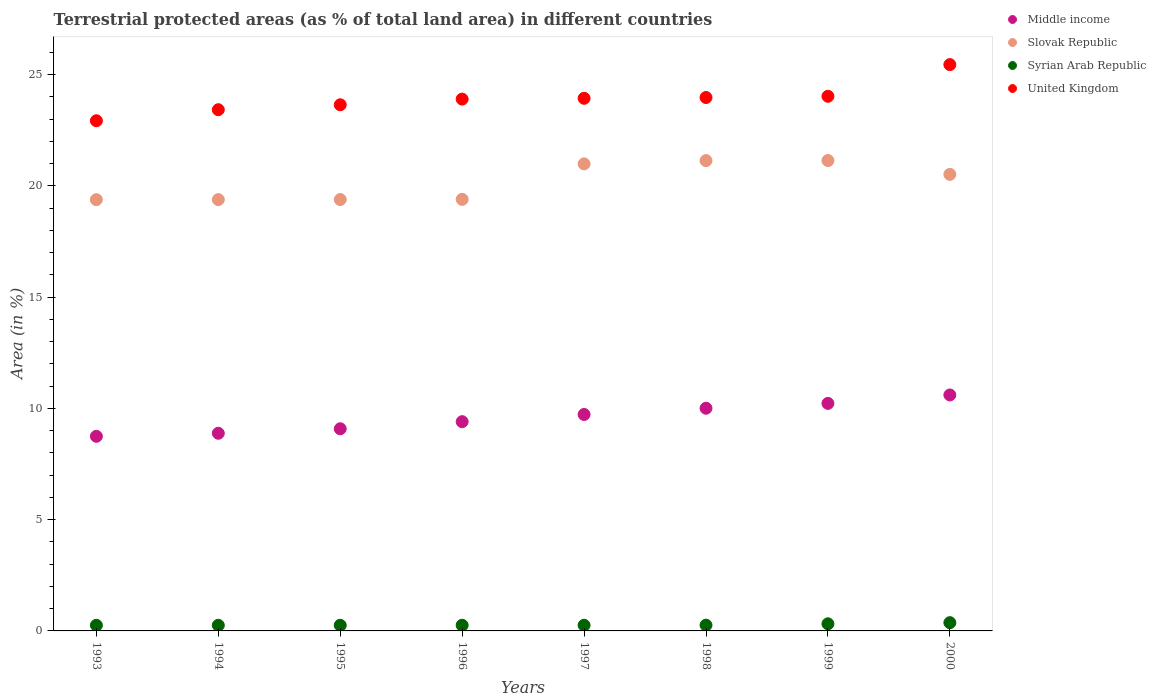Is the number of dotlines equal to the number of legend labels?
Your answer should be compact. Yes. What is the percentage of terrestrial protected land in Syrian Arab Republic in 1997?
Provide a succinct answer. 0.25. Across all years, what is the maximum percentage of terrestrial protected land in Syrian Arab Republic?
Keep it short and to the point. 0.37. Across all years, what is the minimum percentage of terrestrial protected land in United Kingdom?
Provide a short and direct response. 22.93. In which year was the percentage of terrestrial protected land in Slovak Republic minimum?
Your answer should be very brief. 1993. What is the total percentage of terrestrial protected land in Syrian Arab Republic in the graph?
Make the answer very short. 2.22. What is the difference between the percentage of terrestrial protected land in United Kingdom in 1993 and that in 1997?
Offer a terse response. -1.01. What is the difference between the percentage of terrestrial protected land in United Kingdom in 1994 and the percentage of terrestrial protected land in Slovak Republic in 1995?
Your answer should be very brief. 4.04. What is the average percentage of terrestrial protected land in United Kingdom per year?
Offer a terse response. 23.91. In the year 1997, what is the difference between the percentage of terrestrial protected land in Syrian Arab Republic and percentage of terrestrial protected land in Middle income?
Provide a short and direct response. -9.47. In how many years, is the percentage of terrestrial protected land in Middle income greater than 2 %?
Provide a succinct answer. 8. What is the ratio of the percentage of terrestrial protected land in Middle income in 1999 to that in 2000?
Provide a short and direct response. 0.96. Is the percentage of terrestrial protected land in Syrian Arab Republic in 1997 less than that in 1999?
Your response must be concise. Yes. Is the difference between the percentage of terrestrial protected land in Syrian Arab Republic in 1996 and 1999 greater than the difference between the percentage of terrestrial protected land in Middle income in 1996 and 1999?
Ensure brevity in your answer.  Yes. What is the difference between the highest and the second highest percentage of terrestrial protected land in Middle income?
Your answer should be very brief. 0.38. What is the difference between the highest and the lowest percentage of terrestrial protected land in Middle income?
Make the answer very short. 1.86. In how many years, is the percentage of terrestrial protected land in Slovak Republic greater than the average percentage of terrestrial protected land in Slovak Republic taken over all years?
Give a very brief answer. 4. Is the sum of the percentage of terrestrial protected land in Middle income in 1994 and 1999 greater than the maximum percentage of terrestrial protected land in United Kingdom across all years?
Provide a short and direct response. No. Is it the case that in every year, the sum of the percentage of terrestrial protected land in Syrian Arab Republic and percentage of terrestrial protected land in Middle income  is greater than the sum of percentage of terrestrial protected land in United Kingdom and percentage of terrestrial protected land in Slovak Republic?
Provide a short and direct response. No. Does the percentage of terrestrial protected land in Middle income monotonically increase over the years?
Your response must be concise. Yes. How many dotlines are there?
Your answer should be very brief. 4. How many years are there in the graph?
Give a very brief answer. 8. What is the difference between two consecutive major ticks on the Y-axis?
Give a very brief answer. 5. Are the values on the major ticks of Y-axis written in scientific E-notation?
Offer a very short reply. No. Where does the legend appear in the graph?
Your response must be concise. Top right. How many legend labels are there?
Offer a terse response. 4. How are the legend labels stacked?
Keep it short and to the point. Vertical. What is the title of the graph?
Provide a short and direct response. Terrestrial protected areas (as % of total land area) in different countries. Does "Zambia" appear as one of the legend labels in the graph?
Offer a terse response. No. What is the label or title of the X-axis?
Give a very brief answer. Years. What is the label or title of the Y-axis?
Your response must be concise. Area (in %). What is the Area (in %) in Middle income in 1993?
Ensure brevity in your answer.  8.75. What is the Area (in %) of Slovak Republic in 1993?
Provide a succinct answer. 19.38. What is the Area (in %) of Syrian Arab Republic in 1993?
Ensure brevity in your answer.  0.25. What is the Area (in %) in United Kingdom in 1993?
Your answer should be very brief. 22.93. What is the Area (in %) in Middle income in 1994?
Give a very brief answer. 8.88. What is the Area (in %) of Slovak Republic in 1994?
Ensure brevity in your answer.  19.38. What is the Area (in %) of Syrian Arab Republic in 1994?
Make the answer very short. 0.25. What is the Area (in %) in United Kingdom in 1994?
Provide a succinct answer. 23.43. What is the Area (in %) in Middle income in 1995?
Offer a very short reply. 9.09. What is the Area (in %) in Slovak Republic in 1995?
Provide a succinct answer. 19.39. What is the Area (in %) in Syrian Arab Republic in 1995?
Offer a terse response. 0.25. What is the Area (in %) in United Kingdom in 1995?
Offer a very short reply. 23.65. What is the Area (in %) in Middle income in 1996?
Ensure brevity in your answer.  9.4. What is the Area (in %) in Slovak Republic in 1996?
Make the answer very short. 19.4. What is the Area (in %) of Syrian Arab Republic in 1996?
Offer a very short reply. 0.25. What is the Area (in %) of United Kingdom in 1996?
Your answer should be very brief. 23.9. What is the Area (in %) of Middle income in 1997?
Your response must be concise. 9.73. What is the Area (in %) in Slovak Republic in 1997?
Keep it short and to the point. 20.99. What is the Area (in %) of Syrian Arab Republic in 1997?
Keep it short and to the point. 0.25. What is the Area (in %) of United Kingdom in 1997?
Your answer should be compact. 23.94. What is the Area (in %) of Middle income in 1998?
Ensure brevity in your answer.  10.01. What is the Area (in %) of Slovak Republic in 1998?
Give a very brief answer. 21.14. What is the Area (in %) in Syrian Arab Republic in 1998?
Provide a short and direct response. 0.26. What is the Area (in %) of United Kingdom in 1998?
Your response must be concise. 23.97. What is the Area (in %) in Middle income in 1999?
Provide a succinct answer. 10.23. What is the Area (in %) in Slovak Republic in 1999?
Give a very brief answer. 21.14. What is the Area (in %) of Syrian Arab Republic in 1999?
Keep it short and to the point. 0.32. What is the Area (in %) in United Kingdom in 1999?
Your answer should be very brief. 24.03. What is the Area (in %) of Middle income in 2000?
Your answer should be compact. 10.61. What is the Area (in %) of Slovak Republic in 2000?
Keep it short and to the point. 20.52. What is the Area (in %) in Syrian Arab Republic in 2000?
Your answer should be compact. 0.37. What is the Area (in %) in United Kingdom in 2000?
Your answer should be very brief. 25.45. Across all years, what is the maximum Area (in %) of Middle income?
Your response must be concise. 10.61. Across all years, what is the maximum Area (in %) of Slovak Republic?
Keep it short and to the point. 21.14. Across all years, what is the maximum Area (in %) in Syrian Arab Republic?
Offer a terse response. 0.37. Across all years, what is the maximum Area (in %) of United Kingdom?
Your answer should be very brief. 25.45. Across all years, what is the minimum Area (in %) in Middle income?
Your answer should be compact. 8.75. Across all years, what is the minimum Area (in %) in Slovak Republic?
Offer a terse response. 19.38. Across all years, what is the minimum Area (in %) in Syrian Arab Republic?
Your response must be concise. 0.25. Across all years, what is the minimum Area (in %) in United Kingdom?
Make the answer very short. 22.93. What is the total Area (in %) in Middle income in the graph?
Your answer should be very brief. 76.69. What is the total Area (in %) of Slovak Republic in the graph?
Give a very brief answer. 161.34. What is the total Area (in %) of Syrian Arab Republic in the graph?
Your answer should be compact. 2.22. What is the total Area (in %) of United Kingdom in the graph?
Provide a succinct answer. 191.3. What is the difference between the Area (in %) of Middle income in 1993 and that in 1994?
Ensure brevity in your answer.  -0.14. What is the difference between the Area (in %) in Slovak Republic in 1993 and that in 1994?
Provide a succinct answer. -0. What is the difference between the Area (in %) in Syrian Arab Republic in 1993 and that in 1994?
Ensure brevity in your answer.  0. What is the difference between the Area (in %) of United Kingdom in 1993 and that in 1994?
Your response must be concise. -0.5. What is the difference between the Area (in %) in Middle income in 1993 and that in 1995?
Offer a very short reply. -0.34. What is the difference between the Area (in %) in Slovak Republic in 1993 and that in 1995?
Your answer should be compact. -0.01. What is the difference between the Area (in %) in United Kingdom in 1993 and that in 1995?
Provide a short and direct response. -0.72. What is the difference between the Area (in %) in Middle income in 1993 and that in 1996?
Keep it short and to the point. -0.66. What is the difference between the Area (in %) of Slovak Republic in 1993 and that in 1996?
Offer a very short reply. -0.01. What is the difference between the Area (in %) in Syrian Arab Republic in 1993 and that in 1996?
Your answer should be very brief. -0. What is the difference between the Area (in %) of United Kingdom in 1993 and that in 1996?
Provide a short and direct response. -0.97. What is the difference between the Area (in %) of Middle income in 1993 and that in 1997?
Give a very brief answer. -0.98. What is the difference between the Area (in %) of Slovak Republic in 1993 and that in 1997?
Your response must be concise. -1.61. What is the difference between the Area (in %) in Syrian Arab Republic in 1993 and that in 1997?
Your answer should be compact. -0. What is the difference between the Area (in %) in United Kingdom in 1993 and that in 1997?
Offer a terse response. -1.01. What is the difference between the Area (in %) of Middle income in 1993 and that in 1998?
Your answer should be very brief. -1.26. What is the difference between the Area (in %) of Slovak Republic in 1993 and that in 1998?
Give a very brief answer. -1.76. What is the difference between the Area (in %) in Syrian Arab Republic in 1993 and that in 1998?
Your response must be concise. -0.01. What is the difference between the Area (in %) in United Kingdom in 1993 and that in 1998?
Provide a succinct answer. -1.04. What is the difference between the Area (in %) of Middle income in 1993 and that in 1999?
Your answer should be very brief. -1.48. What is the difference between the Area (in %) of Slovak Republic in 1993 and that in 1999?
Offer a terse response. -1.76. What is the difference between the Area (in %) of Syrian Arab Republic in 1993 and that in 1999?
Provide a succinct answer. -0.07. What is the difference between the Area (in %) in United Kingdom in 1993 and that in 1999?
Provide a short and direct response. -1.1. What is the difference between the Area (in %) in Middle income in 1993 and that in 2000?
Provide a succinct answer. -1.86. What is the difference between the Area (in %) in Slovak Republic in 1993 and that in 2000?
Your answer should be compact. -1.14. What is the difference between the Area (in %) of Syrian Arab Republic in 1993 and that in 2000?
Offer a very short reply. -0.12. What is the difference between the Area (in %) of United Kingdom in 1993 and that in 2000?
Make the answer very short. -2.52. What is the difference between the Area (in %) in Middle income in 1994 and that in 1995?
Offer a very short reply. -0.2. What is the difference between the Area (in %) in Slovak Republic in 1994 and that in 1995?
Ensure brevity in your answer.  -0. What is the difference between the Area (in %) in United Kingdom in 1994 and that in 1995?
Offer a terse response. -0.22. What is the difference between the Area (in %) of Middle income in 1994 and that in 1996?
Your answer should be very brief. -0.52. What is the difference between the Area (in %) in Slovak Republic in 1994 and that in 1996?
Your answer should be compact. -0.01. What is the difference between the Area (in %) of Syrian Arab Republic in 1994 and that in 1996?
Your response must be concise. -0. What is the difference between the Area (in %) in United Kingdom in 1994 and that in 1996?
Provide a short and direct response. -0.48. What is the difference between the Area (in %) of Middle income in 1994 and that in 1997?
Your response must be concise. -0.85. What is the difference between the Area (in %) of Slovak Republic in 1994 and that in 1997?
Offer a terse response. -1.61. What is the difference between the Area (in %) of Syrian Arab Republic in 1994 and that in 1997?
Keep it short and to the point. -0. What is the difference between the Area (in %) in United Kingdom in 1994 and that in 1997?
Offer a very short reply. -0.51. What is the difference between the Area (in %) in Middle income in 1994 and that in 1998?
Keep it short and to the point. -1.13. What is the difference between the Area (in %) in Slovak Republic in 1994 and that in 1998?
Your response must be concise. -1.75. What is the difference between the Area (in %) in Syrian Arab Republic in 1994 and that in 1998?
Provide a short and direct response. -0.01. What is the difference between the Area (in %) of United Kingdom in 1994 and that in 1998?
Your answer should be very brief. -0.55. What is the difference between the Area (in %) of Middle income in 1994 and that in 1999?
Give a very brief answer. -1.34. What is the difference between the Area (in %) in Slovak Republic in 1994 and that in 1999?
Provide a short and direct response. -1.76. What is the difference between the Area (in %) in Syrian Arab Republic in 1994 and that in 1999?
Offer a terse response. -0.07. What is the difference between the Area (in %) in United Kingdom in 1994 and that in 1999?
Provide a short and direct response. -0.6. What is the difference between the Area (in %) in Middle income in 1994 and that in 2000?
Keep it short and to the point. -1.72. What is the difference between the Area (in %) in Slovak Republic in 1994 and that in 2000?
Provide a succinct answer. -1.13. What is the difference between the Area (in %) in Syrian Arab Republic in 1994 and that in 2000?
Provide a short and direct response. -0.12. What is the difference between the Area (in %) in United Kingdom in 1994 and that in 2000?
Provide a succinct answer. -2.03. What is the difference between the Area (in %) in Middle income in 1995 and that in 1996?
Keep it short and to the point. -0.32. What is the difference between the Area (in %) of Slovak Republic in 1995 and that in 1996?
Offer a terse response. -0.01. What is the difference between the Area (in %) of Syrian Arab Republic in 1995 and that in 1996?
Ensure brevity in your answer.  -0. What is the difference between the Area (in %) of United Kingdom in 1995 and that in 1996?
Offer a terse response. -0.26. What is the difference between the Area (in %) of Middle income in 1995 and that in 1997?
Offer a terse response. -0.64. What is the difference between the Area (in %) in Slovak Republic in 1995 and that in 1997?
Provide a succinct answer. -1.6. What is the difference between the Area (in %) in Syrian Arab Republic in 1995 and that in 1997?
Keep it short and to the point. -0. What is the difference between the Area (in %) in United Kingdom in 1995 and that in 1997?
Give a very brief answer. -0.29. What is the difference between the Area (in %) in Middle income in 1995 and that in 1998?
Offer a terse response. -0.92. What is the difference between the Area (in %) in Slovak Republic in 1995 and that in 1998?
Ensure brevity in your answer.  -1.75. What is the difference between the Area (in %) of Syrian Arab Republic in 1995 and that in 1998?
Offer a terse response. -0.01. What is the difference between the Area (in %) of United Kingdom in 1995 and that in 1998?
Your answer should be compact. -0.33. What is the difference between the Area (in %) of Middle income in 1995 and that in 1999?
Make the answer very short. -1.14. What is the difference between the Area (in %) in Slovak Republic in 1995 and that in 1999?
Make the answer very short. -1.75. What is the difference between the Area (in %) of Syrian Arab Republic in 1995 and that in 1999?
Make the answer very short. -0.07. What is the difference between the Area (in %) of United Kingdom in 1995 and that in 1999?
Offer a terse response. -0.38. What is the difference between the Area (in %) in Middle income in 1995 and that in 2000?
Offer a very short reply. -1.52. What is the difference between the Area (in %) in Slovak Republic in 1995 and that in 2000?
Offer a terse response. -1.13. What is the difference between the Area (in %) in Syrian Arab Republic in 1995 and that in 2000?
Give a very brief answer. -0.12. What is the difference between the Area (in %) of United Kingdom in 1995 and that in 2000?
Give a very brief answer. -1.81. What is the difference between the Area (in %) in Middle income in 1996 and that in 1997?
Your answer should be very brief. -0.32. What is the difference between the Area (in %) of Slovak Republic in 1996 and that in 1997?
Ensure brevity in your answer.  -1.59. What is the difference between the Area (in %) in Syrian Arab Republic in 1996 and that in 1997?
Provide a short and direct response. 0. What is the difference between the Area (in %) of United Kingdom in 1996 and that in 1997?
Provide a succinct answer. -0.04. What is the difference between the Area (in %) in Middle income in 1996 and that in 1998?
Offer a very short reply. -0.6. What is the difference between the Area (in %) in Slovak Republic in 1996 and that in 1998?
Offer a very short reply. -1.74. What is the difference between the Area (in %) in Syrian Arab Republic in 1996 and that in 1998?
Provide a succinct answer. -0.01. What is the difference between the Area (in %) in United Kingdom in 1996 and that in 1998?
Keep it short and to the point. -0.07. What is the difference between the Area (in %) of Middle income in 1996 and that in 1999?
Keep it short and to the point. -0.82. What is the difference between the Area (in %) in Slovak Republic in 1996 and that in 1999?
Keep it short and to the point. -1.74. What is the difference between the Area (in %) of Syrian Arab Republic in 1996 and that in 1999?
Ensure brevity in your answer.  -0.07. What is the difference between the Area (in %) of United Kingdom in 1996 and that in 1999?
Your answer should be compact. -0.13. What is the difference between the Area (in %) in Middle income in 1996 and that in 2000?
Offer a very short reply. -1.2. What is the difference between the Area (in %) in Slovak Republic in 1996 and that in 2000?
Provide a succinct answer. -1.12. What is the difference between the Area (in %) of Syrian Arab Republic in 1996 and that in 2000?
Provide a short and direct response. -0.12. What is the difference between the Area (in %) in United Kingdom in 1996 and that in 2000?
Offer a terse response. -1.55. What is the difference between the Area (in %) in Middle income in 1997 and that in 1998?
Your answer should be very brief. -0.28. What is the difference between the Area (in %) of Slovak Republic in 1997 and that in 1998?
Give a very brief answer. -0.15. What is the difference between the Area (in %) of Syrian Arab Republic in 1997 and that in 1998?
Keep it short and to the point. -0.01. What is the difference between the Area (in %) of United Kingdom in 1997 and that in 1998?
Provide a short and direct response. -0.04. What is the difference between the Area (in %) in Middle income in 1997 and that in 1999?
Your answer should be compact. -0.5. What is the difference between the Area (in %) in Slovak Republic in 1997 and that in 1999?
Keep it short and to the point. -0.15. What is the difference between the Area (in %) in Syrian Arab Republic in 1997 and that in 1999?
Provide a succinct answer. -0.07. What is the difference between the Area (in %) in United Kingdom in 1997 and that in 1999?
Offer a terse response. -0.09. What is the difference between the Area (in %) of Middle income in 1997 and that in 2000?
Ensure brevity in your answer.  -0.88. What is the difference between the Area (in %) in Slovak Republic in 1997 and that in 2000?
Give a very brief answer. 0.47. What is the difference between the Area (in %) of Syrian Arab Republic in 1997 and that in 2000?
Give a very brief answer. -0.12. What is the difference between the Area (in %) in United Kingdom in 1997 and that in 2000?
Your answer should be compact. -1.51. What is the difference between the Area (in %) of Middle income in 1998 and that in 1999?
Ensure brevity in your answer.  -0.22. What is the difference between the Area (in %) in Slovak Republic in 1998 and that in 1999?
Your response must be concise. -0. What is the difference between the Area (in %) in Syrian Arab Republic in 1998 and that in 1999?
Give a very brief answer. -0.06. What is the difference between the Area (in %) in United Kingdom in 1998 and that in 1999?
Your response must be concise. -0.05. What is the difference between the Area (in %) in Middle income in 1998 and that in 2000?
Provide a short and direct response. -0.6. What is the difference between the Area (in %) of Slovak Republic in 1998 and that in 2000?
Keep it short and to the point. 0.62. What is the difference between the Area (in %) in Syrian Arab Republic in 1998 and that in 2000?
Offer a very short reply. -0.11. What is the difference between the Area (in %) of United Kingdom in 1998 and that in 2000?
Your answer should be very brief. -1.48. What is the difference between the Area (in %) of Middle income in 1999 and that in 2000?
Provide a short and direct response. -0.38. What is the difference between the Area (in %) in Slovak Republic in 1999 and that in 2000?
Offer a terse response. 0.62. What is the difference between the Area (in %) in Syrian Arab Republic in 1999 and that in 2000?
Keep it short and to the point. -0.05. What is the difference between the Area (in %) in United Kingdom in 1999 and that in 2000?
Your answer should be compact. -1.42. What is the difference between the Area (in %) in Middle income in 1993 and the Area (in %) in Slovak Republic in 1994?
Provide a succinct answer. -10.64. What is the difference between the Area (in %) in Middle income in 1993 and the Area (in %) in Syrian Arab Republic in 1994?
Offer a terse response. 8.49. What is the difference between the Area (in %) of Middle income in 1993 and the Area (in %) of United Kingdom in 1994?
Your response must be concise. -14.68. What is the difference between the Area (in %) in Slovak Republic in 1993 and the Area (in %) in Syrian Arab Republic in 1994?
Give a very brief answer. 19.13. What is the difference between the Area (in %) in Slovak Republic in 1993 and the Area (in %) in United Kingdom in 1994?
Give a very brief answer. -4.04. What is the difference between the Area (in %) in Syrian Arab Republic in 1993 and the Area (in %) in United Kingdom in 1994?
Keep it short and to the point. -23.17. What is the difference between the Area (in %) of Middle income in 1993 and the Area (in %) of Slovak Republic in 1995?
Make the answer very short. -10.64. What is the difference between the Area (in %) in Middle income in 1993 and the Area (in %) in Syrian Arab Republic in 1995?
Provide a succinct answer. 8.49. What is the difference between the Area (in %) in Middle income in 1993 and the Area (in %) in United Kingdom in 1995?
Your answer should be very brief. -14.9. What is the difference between the Area (in %) in Slovak Republic in 1993 and the Area (in %) in Syrian Arab Republic in 1995?
Give a very brief answer. 19.13. What is the difference between the Area (in %) in Slovak Republic in 1993 and the Area (in %) in United Kingdom in 1995?
Your answer should be very brief. -4.26. What is the difference between the Area (in %) in Syrian Arab Republic in 1993 and the Area (in %) in United Kingdom in 1995?
Provide a short and direct response. -23.39. What is the difference between the Area (in %) of Middle income in 1993 and the Area (in %) of Slovak Republic in 1996?
Ensure brevity in your answer.  -10.65. What is the difference between the Area (in %) of Middle income in 1993 and the Area (in %) of Syrian Arab Republic in 1996?
Ensure brevity in your answer.  8.49. What is the difference between the Area (in %) in Middle income in 1993 and the Area (in %) in United Kingdom in 1996?
Your answer should be compact. -15.16. What is the difference between the Area (in %) of Slovak Republic in 1993 and the Area (in %) of Syrian Arab Republic in 1996?
Provide a succinct answer. 19.13. What is the difference between the Area (in %) in Slovak Republic in 1993 and the Area (in %) in United Kingdom in 1996?
Your answer should be compact. -4.52. What is the difference between the Area (in %) in Syrian Arab Republic in 1993 and the Area (in %) in United Kingdom in 1996?
Provide a succinct answer. -23.65. What is the difference between the Area (in %) of Middle income in 1993 and the Area (in %) of Slovak Republic in 1997?
Give a very brief answer. -12.24. What is the difference between the Area (in %) in Middle income in 1993 and the Area (in %) in Syrian Arab Republic in 1997?
Offer a terse response. 8.49. What is the difference between the Area (in %) of Middle income in 1993 and the Area (in %) of United Kingdom in 1997?
Make the answer very short. -15.19. What is the difference between the Area (in %) of Slovak Republic in 1993 and the Area (in %) of Syrian Arab Republic in 1997?
Ensure brevity in your answer.  19.13. What is the difference between the Area (in %) in Slovak Republic in 1993 and the Area (in %) in United Kingdom in 1997?
Make the answer very short. -4.56. What is the difference between the Area (in %) in Syrian Arab Republic in 1993 and the Area (in %) in United Kingdom in 1997?
Provide a short and direct response. -23.69. What is the difference between the Area (in %) of Middle income in 1993 and the Area (in %) of Slovak Republic in 1998?
Offer a very short reply. -12.39. What is the difference between the Area (in %) in Middle income in 1993 and the Area (in %) in Syrian Arab Republic in 1998?
Your answer should be very brief. 8.49. What is the difference between the Area (in %) in Middle income in 1993 and the Area (in %) in United Kingdom in 1998?
Your response must be concise. -15.23. What is the difference between the Area (in %) of Slovak Republic in 1993 and the Area (in %) of Syrian Arab Republic in 1998?
Your answer should be compact. 19.12. What is the difference between the Area (in %) of Slovak Republic in 1993 and the Area (in %) of United Kingdom in 1998?
Offer a terse response. -4.59. What is the difference between the Area (in %) of Syrian Arab Republic in 1993 and the Area (in %) of United Kingdom in 1998?
Provide a short and direct response. -23.72. What is the difference between the Area (in %) in Middle income in 1993 and the Area (in %) in Slovak Republic in 1999?
Your answer should be very brief. -12.39. What is the difference between the Area (in %) in Middle income in 1993 and the Area (in %) in Syrian Arab Republic in 1999?
Your answer should be compact. 8.43. What is the difference between the Area (in %) of Middle income in 1993 and the Area (in %) of United Kingdom in 1999?
Your response must be concise. -15.28. What is the difference between the Area (in %) of Slovak Republic in 1993 and the Area (in %) of Syrian Arab Republic in 1999?
Make the answer very short. 19.06. What is the difference between the Area (in %) of Slovak Republic in 1993 and the Area (in %) of United Kingdom in 1999?
Ensure brevity in your answer.  -4.65. What is the difference between the Area (in %) of Syrian Arab Republic in 1993 and the Area (in %) of United Kingdom in 1999?
Offer a terse response. -23.77. What is the difference between the Area (in %) of Middle income in 1993 and the Area (in %) of Slovak Republic in 2000?
Keep it short and to the point. -11.77. What is the difference between the Area (in %) of Middle income in 1993 and the Area (in %) of Syrian Arab Republic in 2000?
Provide a succinct answer. 8.38. What is the difference between the Area (in %) of Middle income in 1993 and the Area (in %) of United Kingdom in 2000?
Make the answer very short. -16.71. What is the difference between the Area (in %) of Slovak Republic in 1993 and the Area (in %) of Syrian Arab Republic in 2000?
Your answer should be very brief. 19.01. What is the difference between the Area (in %) in Slovak Republic in 1993 and the Area (in %) in United Kingdom in 2000?
Provide a succinct answer. -6.07. What is the difference between the Area (in %) in Syrian Arab Republic in 1993 and the Area (in %) in United Kingdom in 2000?
Your answer should be very brief. -25.2. What is the difference between the Area (in %) in Middle income in 1994 and the Area (in %) in Slovak Republic in 1995?
Give a very brief answer. -10.51. What is the difference between the Area (in %) of Middle income in 1994 and the Area (in %) of Syrian Arab Republic in 1995?
Your response must be concise. 8.63. What is the difference between the Area (in %) in Middle income in 1994 and the Area (in %) in United Kingdom in 1995?
Offer a terse response. -14.76. What is the difference between the Area (in %) in Slovak Republic in 1994 and the Area (in %) in Syrian Arab Republic in 1995?
Your answer should be very brief. 19.13. What is the difference between the Area (in %) of Slovak Republic in 1994 and the Area (in %) of United Kingdom in 1995?
Make the answer very short. -4.26. What is the difference between the Area (in %) in Syrian Arab Republic in 1994 and the Area (in %) in United Kingdom in 1995?
Make the answer very short. -23.39. What is the difference between the Area (in %) of Middle income in 1994 and the Area (in %) of Slovak Republic in 1996?
Make the answer very short. -10.51. What is the difference between the Area (in %) of Middle income in 1994 and the Area (in %) of Syrian Arab Republic in 1996?
Provide a succinct answer. 8.63. What is the difference between the Area (in %) of Middle income in 1994 and the Area (in %) of United Kingdom in 1996?
Your answer should be very brief. -15.02. What is the difference between the Area (in %) of Slovak Republic in 1994 and the Area (in %) of Syrian Arab Republic in 1996?
Keep it short and to the point. 19.13. What is the difference between the Area (in %) of Slovak Republic in 1994 and the Area (in %) of United Kingdom in 1996?
Give a very brief answer. -4.52. What is the difference between the Area (in %) in Syrian Arab Republic in 1994 and the Area (in %) in United Kingdom in 1996?
Give a very brief answer. -23.65. What is the difference between the Area (in %) of Middle income in 1994 and the Area (in %) of Slovak Republic in 1997?
Make the answer very short. -12.11. What is the difference between the Area (in %) in Middle income in 1994 and the Area (in %) in Syrian Arab Republic in 1997?
Keep it short and to the point. 8.63. What is the difference between the Area (in %) of Middle income in 1994 and the Area (in %) of United Kingdom in 1997?
Your response must be concise. -15.06. What is the difference between the Area (in %) in Slovak Republic in 1994 and the Area (in %) in Syrian Arab Republic in 1997?
Provide a short and direct response. 19.13. What is the difference between the Area (in %) of Slovak Republic in 1994 and the Area (in %) of United Kingdom in 1997?
Make the answer very short. -4.55. What is the difference between the Area (in %) in Syrian Arab Republic in 1994 and the Area (in %) in United Kingdom in 1997?
Your answer should be very brief. -23.69. What is the difference between the Area (in %) of Middle income in 1994 and the Area (in %) of Slovak Republic in 1998?
Your response must be concise. -12.25. What is the difference between the Area (in %) in Middle income in 1994 and the Area (in %) in Syrian Arab Republic in 1998?
Provide a succinct answer. 8.62. What is the difference between the Area (in %) in Middle income in 1994 and the Area (in %) in United Kingdom in 1998?
Provide a succinct answer. -15.09. What is the difference between the Area (in %) of Slovak Republic in 1994 and the Area (in %) of Syrian Arab Republic in 1998?
Your answer should be compact. 19.13. What is the difference between the Area (in %) in Slovak Republic in 1994 and the Area (in %) in United Kingdom in 1998?
Keep it short and to the point. -4.59. What is the difference between the Area (in %) of Syrian Arab Republic in 1994 and the Area (in %) of United Kingdom in 1998?
Your answer should be very brief. -23.72. What is the difference between the Area (in %) in Middle income in 1994 and the Area (in %) in Slovak Republic in 1999?
Provide a short and direct response. -12.26. What is the difference between the Area (in %) in Middle income in 1994 and the Area (in %) in Syrian Arab Republic in 1999?
Make the answer very short. 8.56. What is the difference between the Area (in %) in Middle income in 1994 and the Area (in %) in United Kingdom in 1999?
Your answer should be very brief. -15.15. What is the difference between the Area (in %) of Slovak Republic in 1994 and the Area (in %) of Syrian Arab Republic in 1999?
Offer a terse response. 19.06. What is the difference between the Area (in %) in Slovak Republic in 1994 and the Area (in %) in United Kingdom in 1999?
Your answer should be very brief. -4.64. What is the difference between the Area (in %) in Syrian Arab Republic in 1994 and the Area (in %) in United Kingdom in 1999?
Give a very brief answer. -23.77. What is the difference between the Area (in %) in Middle income in 1994 and the Area (in %) in Slovak Republic in 2000?
Your response must be concise. -11.64. What is the difference between the Area (in %) in Middle income in 1994 and the Area (in %) in Syrian Arab Republic in 2000?
Provide a succinct answer. 8.51. What is the difference between the Area (in %) of Middle income in 1994 and the Area (in %) of United Kingdom in 2000?
Your answer should be compact. -16.57. What is the difference between the Area (in %) in Slovak Republic in 1994 and the Area (in %) in Syrian Arab Republic in 2000?
Your answer should be very brief. 19.01. What is the difference between the Area (in %) of Slovak Republic in 1994 and the Area (in %) of United Kingdom in 2000?
Provide a short and direct response. -6.07. What is the difference between the Area (in %) in Syrian Arab Republic in 1994 and the Area (in %) in United Kingdom in 2000?
Make the answer very short. -25.2. What is the difference between the Area (in %) of Middle income in 1995 and the Area (in %) of Slovak Republic in 1996?
Ensure brevity in your answer.  -10.31. What is the difference between the Area (in %) in Middle income in 1995 and the Area (in %) in Syrian Arab Republic in 1996?
Offer a very short reply. 8.83. What is the difference between the Area (in %) in Middle income in 1995 and the Area (in %) in United Kingdom in 1996?
Make the answer very short. -14.82. What is the difference between the Area (in %) of Slovak Republic in 1995 and the Area (in %) of Syrian Arab Republic in 1996?
Offer a terse response. 19.13. What is the difference between the Area (in %) in Slovak Republic in 1995 and the Area (in %) in United Kingdom in 1996?
Provide a succinct answer. -4.51. What is the difference between the Area (in %) of Syrian Arab Republic in 1995 and the Area (in %) of United Kingdom in 1996?
Keep it short and to the point. -23.65. What is the difference between the Area (in %) of Middle income in 1995 and the Area (in %) of Slovak Republic in 1997?
Ensure brevity in your answer.  -11.91. What is the difference between the Area (in %) of Middle income in 1995 and the Area (in %) of Syrian Arab Republic in 1997?
Your answer should be very brief. 8.83. What is the difference between the Area (in %) in Middle income in 1995 and the Area (in %) in United Kingdom in 1997?
Ensure brevity in your answer.  -14.85. What is the difference between the Area (in %) of Slovak Republic in 1995 and the Area (in %) of Syrian Arab Republic in 1997?
Offer a terse response. 19.13. What is the difference between the Area (in %) in Slovak Republic in 1995 and the Area (in %) in United Kingdom in 1997?
Provide a succinct answer. -4.55. What is the difference between the Area (in %) of Syrian Arab Republic in 1995 and the Area (in %) of United Kingdom in 1997?
Make the answer very short. -23.69. What is the difference between the Area (in %) in Middle income in 1995 and the Area (in %) in Slovak Republic in 1998?
Your answer should be compact. -12.05. What is the difference between the Area (in %) in Middle income in 1995 and the Area (in %) in Syrian Arab Republic in 1998?
Make the answer very short. 8.83. What is the difference between the Area (in %) of Middle income in 1995 and the Area (in %) of United Kingdom in 1998?
Ensure brevity in your answer.  -14.89. What is the difference between the Area (in %) of Slovak Republic in 1995 and the Area (in %) of Syrian Arab Republic in 1998?
Keep it short and to the point. 19.13. What is the difference between the Area (in %) in Slovak Republic in 1995 and the Area (in %) in United Kingdom in 1998?
Give a very brief answer. -4.59. What is the difference between the Area (in %) in Syrian Arab Republic in 1995 and the Area (in %) in United Kingdom in 1998?
Your answer should be very brief. -23.72. What is the difference between the Area (in %) in Middle income in 1995 and the Area (in %) in Slovak Republic in 1999?
Provide a succinct answer. -12.06. What is the difference between the Area (in %) of Middle income in 1995 and the Area (in %) of Syrian Arab Republic in 1999?
Offer a terse response. 8.77. What is the difference between the Area (in %) of Middle income in 1995 and the Area (in %) of United Kingdom in 1999?
Provide a succinct answer. -14.94. What is the difference between the Area (in %) in Slovak Republic in 1995 and the Area (in %) in Syrian Arab Republic in 1999?
Provide a succinct answer. 19.07. What is the difference between the Area (in %) in Slovak Republic in 1995 and the Area (in %) in United Kingdom in 1999?
Provide a succinct answer. -4.64. What is the difference between the Area (in %) in Syrian Arab Republic in 1995 and the Area (in %) in United Kingdom in 1999?
Make the answer very short. -23.77. What is the difference between the Area (in %) in Middle income in 1995 and the Area (in %) in Slovak Republic in 2000?
Provide a short and direct response. -11.43. What is the difference between the Area (in %) in Middle income in 1995 and the Area (in %) in Syrian Arab Republic in 2000?
Keep it short and to the point. 8.71. What is the difference between the Area (in %) in Middle income in 1995 and the Area (in %) in United Kingdom in 2000?
Provide a succinct answer. -16.37. What is the difference between the Area (in %) in Slovak Republic in 1995 and the Area (in %) in Syrian Arab Republic in 2000?
Keep it short and to the point. 19.02. What is the difference between the Area (in %) in Slovak Republic in 1995 and the Area (in %) in United Kingdom in 2000?
Keep it short and to the point. -6.06. What is the difference between the Area (in %) in Syrian Arab Republic in 1995 and the Area (in %) in United Kingdom in 2000?
Provide a short and direct response. -25.2. What is the difference between the Area (in %) of Middle income in 1996 and the Area (in %) of Slovak Republic in 1997?
Offer a terse response. -11.59. What is the difference between the Area (in %) of Middle income in 1996 and the Area (in %) of Syrian Arab Republic in 1997?
Your answer should be very brief. 9.15. What is the difference between the Area (in %) of Middle income in 1996 and the Area (in %) of United Kingdom in 1997?
Ensure brevity in your answer.  -14.53. What is the difference between the Area (in %) in Slovak Republic in 1996 and the Area (in %) in Syrian Arab Republic in 1997?
Your answer should be very brief. 19.14. What is the difference between the Area (in %) of Slovak Republic in 1996 and the Area (in %) of United Kingdom in 1997?
Ensure brevity in your answer.  -4.54. What is the difference between the Area (in %) in Syrian Arab Republic in 1996 and the Area (in %) in United Kingdom in 1997?
Provide a short and direct response. -23.68. What is the difference between the Area (in %) in Middle income in 1996 and the Area (in %) in Slovak Republic in 1998?
Your answer should be compact. -11.73. What is the difference between the Area (in %) of Middle income in 1996 and the Area (in %) of Syrian Arab Republic in 1998?
Offer a terse response. 9.15. What is the difference between the Area (in %) of Middle income in 1996 and the Area (in %) of United Kingdom in 1998?
Provide a short and direct response. -14.57. What is the difference between the Area (in %) in Slovak Republic in 1996 and the Area (in %) in Syrian Arab Republic in 1998?
Your answer should be compact. 19.14. What is the difference between the Area (in %) of Slovak Republic in 1996 and the Area (in %) of United Kingdom in 1998?
Ensure brevity in your answer.  -4.58. What is the difference between the Area (in %) in Syrian Arab Republic in 1996 and the Area (in %) in United Kingdom in 1998?
Give a very brief answer. -23.72. What is the difference between the Area (in %) in Middle income in 1996 and the Area (in %) in Slovak Republic in 1999?
Keep it short and to the point. -11.74. What is the difference between the Area (in %) of Middle income in 1996 and the Area (in %) of Syrian Arab Republic in 1999?
Your response must be concise. 9.08. What is the difference between the Area (in %) of Middle income in 1996 and the Area (in %) of United Kingdom in 1999?
Offer a very short reply. -14.62. What is the difference between the Area (in %) of Slovak Republic in 1996 and the Area (in %) of Syrian Arab Republic in 1999?
Offer a very short reply. 19.08. What is the difference between the Area (in %) of Slovak Republic in 1996 and the Area (in %) of United Kingdom in 1999?
Ensure brevity in your answer.  -4.63. What is the difference between the Area (in %) in Syrian Arab Republic in 1996 and the Area (in %) in United Kingdom in 1999?
Give a very brief answer. -23.77. What is the difference between the Area (in %) in Middle income in 1996 and the Area (in %) in Slovak Republic in 2000?
Provide a short and direct response. -11.11. What is the difference between the Area (in %) in Middle income in 1996 and the Area (in %) in Syrian Arab Republic in 2000?
Offer a terse response. 9.03. What is the difference between the Area (in %) of Middle income in 1996 and the Area (in %) of United Kingdom in 2000?
Make the answer very short. -16.05. What is the difference between the Area (in %) of Slovak Republic in 1996 and the Area (in %) of Syrian Arab Republic in 2000?
Provide a short and direct response. 19.03. What is the difference between the Area (in %) in Slovak Republic in 1996 and the Area (in %) in United Kingdom in 2000?
Keep it short and to the point. -6.06. What is the difference between the Area (in %) of Syrian Arab Republic in 1996 and the Area (in %) of United Kingdom in 2000?
Make the answer very short. -25.2. What is the difference between the Area (in %) of Middle income in 1997 and the Area (in %) of Slovak Republic in 1998?
Keep it short and to the point. -11.41. What is the difference between the Area (in %) of Middle income in 1997 and the Area (in %) of Syrian Arab Republic in 1998?
Your answer should be very brief. 9.47. What is the difference between the Area (in %) in Middle income in 1997 and the Area (in %) in United Kingdom in 1998?
Offer a terse response. -14.25. What is the difference between the Area (in %) in Slovak Republic in 1997 and the Area (in %) in Syrian Arab Republic in 1998?
Give a very brief answer. 20.73. What is the difference between the Area (in %) of Slovak Republic in 1997 and the Area (in %) of United Kingdom in 1998?
Provide a short and direct response. -2.98. What is the difference between the Area (in %) in Syrian Arab Republic in 1997 and the Area (in %) in United Kingdom in 1998?
Ensure brevity in your answer.  -23.72. What is the difference between the Area (in %) of Middle income in 1997 and the Area (in %) of Slovak Republic in 1999?
Offer a terse response. -11.41. What is the difference between the Area (in %) of Middle income in 1997 and the Area (in %) of Syrian Arab Republic in 1999?
Your answer should be very brief. 9.41. What is the difference between the Area (in %) in Middle income in 1997 and the Area (in %) in United Kingdom in 1999?
Your answer should be compact. -14.3. What is the difference between the Area (in %) of Slovak Republic in 1997 and the Area (in %) of Syrian Arab Republic in 1999?
Give a very brief answer. 20.67. What is the difference between the Area (in %) of Slovak Republic in 1997 and the Area (in %) of United Kingdom in 1999?
Your answer should be very brief. -3.04. What is the difference between the Area (in %) of Syrian Arab Republic in 1997 and the Area (in %) of United Kingdom in 1999?
Your answer should be compact. -23.77. What is the difference between the Area (in %) of Middle income in 1997 and the Area (in %) of Slovak Republic in 2000?
Provide a short and direct response. -10.79. What is the difference between the Area (in %) of Middle income in 1997 and the Area (in %) of Syrian Arab Republic in 2000?
Make the answer very short. 9.36. What is the difference between the Area (in %) in Middle income in 1997 and the Area (in %) in United Kingdom in 2000?
Provide a short and direct response. -15.72. What is the difference between the Area (in %) in Slovak Republic in 1997 and the Area (in %) in Syrian Arab Republic in 2000?
Keep it short and to the point. 20.62. What is the difference between the Area (in %) of Slovak Republic in 1997 and the Area (in %) of United Kingdom in 2000?
Provide a succinct answer. -4.46. What is the difference between the Area (in %) in Syrian Arab Republic in 1997 and the Area (in %) in United Kingdom in 2000?
Provide a succinct answer. -25.2. What is the difference between the Area (in %) of Middle income in 1998 and the Area (in %) of Slovak Republic in 1999?
Keep it short and to the point. -11.13. What is the difference between the Area (in %) of Middle income in 1998 and the Area (in %) of Syrian Arab Republic in 1999?
Ensure brevity in your answer.  9.69. What is the difference between the Area (in %) of Middle income in 1998 and the Area (in %) of United Kingdom in 1999?
Make the answer very short. -14.02. What is the difference between the Area (in %) of Slovak Republic in 1998 and the Area (in %) of Syrian Arab Republic in 1999?
Provide a succinct answer. 20.82. What is the difference between the Area (in %) of Slovak Republic in 1998 and the Area (in %) of United Kingdom in 1999?
Ensure brevity in your answer.  -2.89. What is the difference between the Area (in %) in Syrian Arab Republic in 1998 and the Area (in %) in United Kingdom in 1999?
Ensure brevity in your answer.  -23.77. What is the difference between the Area (in %) of Middle income in 1998 and the Area (in %) of Slovak Republic in 2000?
Provide a succinct answer. -10.51. What is the difference between the Area (in %) in Middle income in 1998 and the Area (in %) in Syrian Arab Republic in 2000?
Offer a terse response. 9.64. What is the difference between the Area (in %) in Middle income in 1998 and the Area (in %) in United Kingdom in 2000?
Ensure brevity in your answer.  -15.44. What is the difference between the Area (in %) in Slovak Republic in 1998 and the Area (in %) in Syrian Arab Republic in 2000?
Your response must be concise. 20.77. What is the difference between the Area (in %) in Slovak Republic in 1998 and the Area (in %) in United Kingdom in 2000?
Provide a short and direct response. -4.32. What is the difference between the Area (in %) of Syrian Arab Republic in 1998 and the Area (in %) of United Kingdom in 2000?
Give a very brief answer. -25.19. What is the difference between the Area (in %) of Middle income in 1999 and the Area (in %) of Slovak Republic in 2000?
Offer a terse response. -10.29. What is the difference between the Area (in %) of Middle income in 1999 and the Area (in %) of Syrian Arab Republic in 2000?
Make the answer very short. 9.86. What is the difference between the Area (in %) in Middle income in 1999 and the Area (in %) in United Kingdom in 2000?
Provide a succinct answer. -15.23. What is the difference between the Area (in %) in Slovak Republic in 1999 and the Area (in %) in Syrian Arab Republic in 2000?
Provide a succinct answer. 20.77. What is the difference between the Area (in %) of Slovak Republic in 1999 and the Area (in %) of United Kingdom in 2000?
Provide a short and direct response. -4.31. What is the difference between the Area (in %) in Syrian Arab Republic in 1999 and the Area (in %) in United Kingdom in 2000?
Make the answer very short. -25.13. What is the average Area (in %) in Middle income per year?
Provide a short and direct response. 9.59. What is the average Area (in %) in Slovak Republic per year?
Provide a succinct answer. 20.17. What is the average Area (in %) of Syrian Arab Republic per year?
Keep it short and to the point. 0.28. What is the average Area (in %) in United Kingdom per year?
Your answer should be compact. 23.91. In the year 1993, what is the difference between the Area (in %) of Middle income and Area (in %) of Slovak Republic?
Make the answer very short. -10.64. In the year 1993, what is the difference between the Area (in %) in Middle income and Area (in %) in Syrian Arab Republic?
Make the answer very short. 8.49. In the year 1993, what is the difference between the Area (in %) of Middle income and Area (in %) of United Kingdom?
Your answer should be compact. -14.18. In the year 1993, what is the difference between the Area (in %) in Slovak Republic and Area (in %) in Syrian Arab Republic?
Your answer should be compact. 19.13. In the year 1993, what is the difference between the Area (in %) in Slovak Republic and Area (in %) in United Kingdom?
Your response must be concise. -3.55. In the year 1993, what is the difference between the Area (in %) of Syrian Arab Republic and Area (in %) of United Kingdom?
Your response must be concise. -22.68. In the year 1994, what is the difference between the Area (in %) in Middle income and Area (in %) in Slovak Republic?
Give a very brief answer. -10.5. In the year 1994, what is the difference between the Area (in %) in Middle income and Area (in %) in Syrian Arab Republic?
Your answer should be compact. 8.63. In the year 1994, what is the difference between the Area (in %) in Middle income and Area (in %) in United Kingdom?
Make the answer very short. -14.54. In the year 1994, what is the difference between the Area (in %) of Slovak Republic and Area (in %) of Syrian Arab Republic?
Your answer should be compact. 19.13. In the year 1994, what is the difference between the Area (in %) in Slovak Republic and Area (in %) in United Kingdom?
Provide a succinct answer. -4.04. In the year 1994, what is the difference between the Area (in %) in Syrian Arab Republic and Area (in %) in United Kingdom?
Provide a short and direct response. -23.17. In the year 1995, what is the difference between the Area (in %) of Middle income and Area (in %) of Slovak Republic?
Provide a succinct answer. -10.3. In the year 1995, what is the difference between the Area (in %) of Middle income and Area (in %) of Syrian Arab Republic?
Keep it short and to the point. 8.83. In the year 1995, what is the difference between the Area (in %) in Middle income and Area (in %) in United Kingdom?
Give a very brief answer. -14.56. In the year 1995, what is the difference between the Area (in %) in Slovak Republic and Area (in %) in Syrian Arab Republic?
Offer a very short reply. 19.14. In the year 1995, what is the difference between the Area (in %) of Slovak Republic and Area (in %) of United Kingdom?
Your answer should be compact. -4.26. In the year 1995, what is the difference between the Area (in %) in Syrian Arab Republic and Area (in %) in United Kingdom?
Provide a succinct answer. -23.39. In the year 1996, what is the difference between the Area (in %) in Middle income and Area (in %) in Slovak Republic?
Provide a short and direct response. -9.99. In the year 1996, what is the difference between the Area (in %) of Middle income and Area (in %) of Syrian Arab Republic?
Provide a succinct answer. 9.15. In the year 1996, what is the difference between the Area (in %) of Middle income and Area (in %) of United Kingdom?
Your response must be concise. -14.5. In the year 1996, what is the difference between the Area (in %) in Slovak Republic and Area (in %) in Syrian Arab Republic?
Your answer should be compact. 19.14. In the year 1996, what is the difference between the Area (in %) of Slovak Republic and Area (in %) of United Kingdom?
Keep it short and to the point. -4.51. In the year 1996, what is the difference between the Area (in %) of Syrian Arab Republic and Area (in %) of United Kingdom?
Offer a terse response. -23.65. In the year 1997, what is the difference between the Area (in %) in Middle income and Area (in %) in Slovak Republic?
Ensure brevity in your answer.  -11.26. In the year 1997, what is the difference between the Area (in %) of Middle income and Area (in %) of Syrian Arab Republic?
Keep it short and to the point. 9.47. In the year 1997, what is the difference between the Area (in %) of Middle income and Area (in %) of United Kingdom?
Offer a very short reply. -14.21. In the year 1997, what is the difference between the Area (in %) in Slovak Republic and Area (in %) in Syrian Arab Republic?
Give a very brief answer. 20.74. In the year 1997, what is the difference between the Area (in %) in Slovak Republic and Area (in %) in United Kingdom?
Offer a very short reply. -2.95. In the year 1997, what is the difference between the Area (in %) in Syrian Arab Republic and Area (in %) in United Kingdom?
Your answer should be very brief. -23.68. In the year 1998, what is the difference between the Area (in %) of Middle income and Area (in %) of Slovak Republic?
Provide a short and direct response. -11.13. In the year 1998, what is the difference between the Area (in %) in Middle income and Area (in %) in Syrian Arab Republic?
Your answer should be very brief. 9.75. In the year 1998, what is the difference between the Area (in %) in Middle income and Area (in %) in United Kingdom?
Provide a succinct answer. -13.97. In the year 1998, what is the difference between the Area (in %) of Slovak Republic and Area (in %) of Syrian Arab Republic?
Your response must be concise. 20.88. In the year 1998, what is the difference between the Area (in %) of Slovak Republic and Area (in %) of United Kingdom?
Your answer should be very brief. -2.84. In the year 1998, what is the difference between the Area (in %) in Syrian Arab Republic and Area (in %) in United Kingdom?
Offer a terse response. -23.71. In the year 1999, what is the difference between the Area (in %) in Middle income and Area (in %) in Slovak Republic?
Provide a short and direct response. -10.91. In the year 1999, what is the difference between the Area (in %) in Middle income and Area (in %) in Syrian Arab Republic?
Provide a succinct answer. 9.91. In the year 1999, what is the difference between the Area (in %) in Middle income and Area (in %) in United Kingdom?
Ensure brevity in your answer.  -13.8. In the year 1999, what is the difference between the Area (in %) of Slovak Republic and Area (in %) of Syrian Arab Republic?
Ensure brevity in your answer.  20.82. In the year 1999, what is the difference between the Area (in %) in Slovak Republic and Area (in %) in United Kingdom?
Your response must be concise. -2.89. In the year 1999, what is the difference between the Area (in %) in Syrian Arab Republic and Area (in %) in United Kingdom?
Make the answer very short. -23.71. In the year 2000, what is the difference between the Area (in %) of Middle income and Area (in %) of Slovak Republic?
Your answer should be very brief. -9.91. In the year 2000, what is the difference between the Area (in %) of Middle income and Area (in %) of Syrian Arab Republic?
Provide a succinct answer. 10.23. In the year 2000, what is the difference between the Area (in %) in Middle income and Area (in %) in United Kingdom?
Your answer should be compact. -14.85. In the year 2000, what is the difference between the Area (in %) in Slovak Republic and Area (in %) in Syrian Arab Republic?
Give a very brief answer. 20.15. In the year 2000, what is the difference between the Area (in %) of Slovak Republic and Area (in %) of United Kingdom?
Provide a short and direct response. -4.93. In the year 2000, what is the difference between the Area (in %) of Syrian Arab Republic and Area (in %) of United Kingdom?
Your answer should be compact. -25.08. What is the ratio of the Area (in %) in Middle income in 1993 to that in 1994?
Offer a very short reply. 0.98. What is the ratio of the Area (in %) of United Kingdom in 1993 to that in 1994?
Your response must be concise. 0.98. What is the ratio of the Area (in %) of Middle income in 1993 to that in 1995?
Your answer should be compact. 0.96. What is the ratio of the Area (in %) in Syrian Arab Republic in 1993 to that in 1995?
Your answer should be compact. 1. What is the ratio of the Area (in %) in United Kingdom in 1993 to that in 1995?
Provide a short and direct response. 0.97. What is the ratio of the Area (in %) in Slovak Republic in 1993 to that in 1996?
Offer a terse response. 1. What is the ratio of the Area (in %) in Syrian Arab Republic in 1993 to that in 1996?
Ensure brevity in your answer.  1. What is the ratio of the Area (in %) in United Kingdom in 1993 to that in 1996?
Ensure brevity in your answer.  0.96. What is the ratio of the Area (in %) in Middle income in 1993 to that in 1997?
Your answer should be compact. 0.9. What is the ratio of the Area (in %) in Slovak Republic in 1993 to that in 1997?
Your response must be concise. 0.92. What is the ratio of the Area (in %) of Syrian Arab Republic in 1993 to that in 1997?
Keep it short and to the point. 1. What is the ratio of the Area (in %) of United Kingdom in 1993 to that in 1997?
Your answer should be very brief. 0.96. What is the ratio of the Area (in %) in Middle income in 1993 to that in 1998?
Your answer should be very brief. 0.87. What is the ratio of the Area (in %) in Slovak Republic in 1993 to that in 1998?
Keep it short and to the point. 0.92. What is the ratio of the Area (in %) of Syrian Arab Republic in 1993 to that in 1998?
Provide a short and direct response. 0.98. What is the ratio of the Area (in %) in United Kingdom in 1993 to that in 1998?
Provide a short and direct response. 0.96. What is the ratio of the Area (in %) of Middle income in 1993 to that in 1999?
Your response must be concise. 0.86. What is the ratio of the Area (in %) in Slovak Republic in 1993 to that in 1999?
Your answer should be very brief. 0.92. What is the ratio of the Area (in %) of Syrian Arab Republic in 1993 to that in 1999?
Your answer should be very brief. 0.79. What is the ratio of the Area (in %) of United Kingdom in 1993 to that in 1999?
Provide a succinct answer. 0.95. What is the ratio of the Area (in %) in Middle income in 1993 to that in 2000?
Give a very brief answer. 0.82. What is the ratio of the Area (in %) of Slovak Republic in 1993 to that in 2000?
Offer a terse response. 0.94. What is the ratio of the Area (in %) of Syrian Arab Republic in 1993 to that in 2000?
Offer a terse response. 0.68. What is the ratio of the Area (in %) of United Kingdom in 1993 to that in 2000?
Your answer should be very brief. 0.9. What is the ratio of the Area (in %) in Middle income in 1994 to that in 1995?
Offer a very short reply. 0.98. What is the ratio of the Area (in %) in United Kingdom in 1994 to that in 1995?
Your response must be concise. 0.99. What is the ratio of the Area (in %) of Middle income in 1994 to that in 1996?
Your answer should be compact. 0.94. What is the ratio of the Area (in %) in Slovak Republic in 1994 to that in 1996?
Your response must be concise. 1. What is the ratio of the Area (in %) in Syrian Arab Republic in 1994 to that in 1996?
Keep it short and to the point. 1. What is the ratio of the Area (in %) of United Kingdom in 1994 to that in 1996?
Make the answer very short. 0.98. What is the ratio of the Area (in %) in Middle income in 1994 to that in 1997?
Your response must be concise. 0.91. What is the ratio of the Area (in %) in Slovak Republic in 1994 to that in 1997?
Keep it short and to the point. 0.92. What is the ratio of the Area (in %) in Syrian Arab Republic in 1994 to that in 1997?
Keep it short and to the point. 1. What is the ratio of the Area (in %) in United Kingdom in 1994 to that in 1997?
Your answer should be very brief. 0.98. What is the ratio of the Area (in %) of Middle income in 1994 to that in 1998?
Make the answer very short. 0.89. What is the ratio of the Area (in %) of Slovak Republic in 1994 to that in 1998?
Make the answer very short. 0.92. What is the ratio of the Area (in %) of Syrian Arab Republic in 1994 to that in 1998?
Make the answer very short. 0.98. What is the ratio of the Area (in %) of United Kingdom in 1994 to that in 1998?
Your answer should be compact. 0.98. What is the ratio of the Area (in %) of Middle income in 1994 to that in 1999?
Your answer should be compact. 0.87. What is the ratio of the Area (in %) of Slovak Republic in 1994 to that in 1999?
Give a very brief answer. 0.92. What is the ratio of the Area (in %) of Syrian Arab Republic in 1994 to that in 1999?
Give a very brief answer. 0.79. What is the ratio of the Area (in %) in United Kingdom in 1994 to that in 1999?
Ensure brevity in your answer.  0.97. What is the ratio of the Area (in %) of Middle income in 1994 to that in 2000?
Give a very brief answer. 0.84. What is the ratio of the Area (in %) in Slovak Republic in 1994 to that in 2000?
Provide a short and direct response. 0.94. What is the ratio of the Area (in %) of Syrian Arab Republic in 1994 to that in 2000?
Your answer should be compact. 0.68. What is the ratio of the Area (in %) of United Kingdom in 1994 to that in 2000?
Your answer should be compact. 0.92. What is the ratio of the Area (in %) of Middle income in 1995 to that in 1996?
Provide a short and direct response. 0.97. What is the ratio of the Area (in %) of Slovak Republic in 1995 to that in 1996?
Offer a very short reply. 1. What is the ratio of the Area (in %) of United Kingdom in 1995 to that in 1996?
Offer a terse response. 0.99. What is the ratio of the Area (in %) in Middle income in 1995 to that in 1997?
Your answer should be compact. 0.93. What is the ratio of the Area (in %) in Slovak Republic in 1995 to that in 1997?
Your response must be concise. 0.92. What is the ratio of the Area (in %) of United Kingdom in 1995 to that in 1997?
Keep it short and to the point. 0.99. What is the ratio of the Area (in %) of Middle income in 1995 to that in 1998?
Your answer should be very brief. 0.91. What is the ratio of the Area (in %) in Slovak Republic in 1995 to that in 1998?
Ensure brevity in your answer.  0.92. What is the ratio of the Area (in %) in Syrian Arab Republic in 1995 to that in 1998?
Your response must be concise. 0.98. What is the ratio of the Area (in %) of United Kingdom in 1995 to that in 1998?
Provide a short and direct response. 0.99. What is the ratio of the Area (in %) of Middle income in 1995 to that in 1999?
Your answer should be very brief. 0.89. What is the ratio of the Area (in %) in Slovak Republic in 1995 to that in 1999?
Make the answer very short. 0.92. What is the ratio of the Area (in %) in Syrian Arab Republic in 1995 to that in 1999?
Ensure brevity in your answer.  0.79. What is the ratio of the Area (in %) in United Kingdom in 1995 to that in 1999?
Your answer should be compact. 0.98. What is the ratio of the Area (in %) of Middle income in 1995 to that in 2000?
Give a very brief answer. 0.86. What is the ratio of the Area (in %) in Slovak Republic in 1995 to that in 2000?
Make the answer very short. 0.94. What is the ratio of the Area (in %) in Syrian Arab Republic in 1995 to that in 2000?
Ensure brevity in your answer.  0.68. What is the ratio of the Area (in %) of United Kingdom in 1995 to that in 2000?
Your answer should be compact. 0.93. What is the ratio of the Area (in %) of Middle income in 1996 to that in 1997?
Provide a succinct answer. 0.97. What is the ratio of the Area (in %) in Slovak Republic in 1996 to that in 1997?
Offer a terse response. 0.92. What is the ratio of the Area (in %) of United Kingdom in 1996 to that in 1997?
Your answer should be compact. 1. What is the ratio of the Area (in %) in Middle income in 1996 to that in 1998?
Ensure brevity in your answer.  0.94. What is the ratio of the Area (in %) in Slovak Republic in 1996 to that in 1998?
Offer a very short reply. 0.92. What is the ratio of the Area (in %) in Syrian Arab Republic in 1996 to that in 1998?
Keep it short and to the point. 0.98. What is the ratio of the Area (in %) in Middle income in 1996 to that in 1999?
Offer a very short reply. 0.92. What is the ratio of the Area (in %) of Slovak Republic in 1996 to that in 1999?
Provide a succinct answer. 0.92. What is the ratio of the Area (in %) of Syrian Arab Republic in 1996 to that in 1999?
Offer a terse response. 0.79. What is the ratio of the Area (in %) in Middle income in 1996 to that in 2000?
Offer a terse response. 0.89. What is the ratio of the Area (in %) in Slovak Republic in 1996 to that in 2000?
Your response must be concise. 0.95. What is the ratio of the Area (in %) of Syrian Arab Republic in 1996 to that in 2000?
Your answer should be compact. 0.68. What is the ratio of the Area (in %) of United Kingdom in 1996 to that in 2000?
Your answer should be very brief. 0.94. What is the ratio of the Area (in %) in Middle income in 1997 to that in 1998?
Give a very brief answer. 0.97. What is the ratio of the Area (in %) of Syrian Arab Republic in 1997 to that in 1998?
Keep it short and to the point. 0.98. What is the ratio of the Area (in %) of Middle income in 1997 to that in 1999?
Your answer should be very brief. 0.95. What is the ratio of the Area (in %) of Slovak Republic in 1997 to that in 1999?
Give a very brief answer. 0.99. What is the ratio of the Area (in %) of Syrian Arab Republic in 1997 to that in 1999?
Ensure brevity in your answer.  0.79. What is the ratio of the Area (in %) in United Kingdom in 1997 to that in 1999?
Offer a very short reply. 1. What is the ratio of the Area (in %) in Middle income in 1997 to that in 2000?
Provide a short and direct response. 0.92. What is the ratio of the Area (in %) in Slovak Republic in 1997 to that in 2000?
Your answer should be very brief. 1.02. What is the ratio of the Area (in %) in Syrian Arab Republic in 1997 to that in 2000?
Your answer should be compact. 0.68. What is the ratio of the Area (in %) in United Kingdom in 1997 to that in 2000?
Make the answer very short. 0.94. What is the ratio of the Area (in %) of Middle income in 1998 to that in 1999?
Ensure brevity in your answer.  0.98. What is the ratio of the Area (in %) of Syrian Arab Republic in 1998 to that in 1999?
Your response must be concise. 0.81. What is the ratio of the Area (in %) in United Kingdom in 1998 to that in 1999?
Keep it short and to the point. 1. What is the ratio of the Area (in %) in Middle income in 1998 to that in 2000?
Ensure brevity in your answer.  0.94. What is the ratio of the Area (in %) in Slovak Republic in 1998 to that in 2000?
Make the answer very short. 1.03. What is the ratio of the Area (in %) in Syrian Arab Republic in 1998 to that in 2000?
Ensure brevity in your answer.  0.7. What is the ratio of the Area (in %) of United Kingdom in 1998 to that in 2000?
Provide a succinct answer. 0.94. What is the ratio of the Area (in %) in Middle income in 1999 to that in 2000?
Give a very brief answer. 0.96. What is the ratio of the Area (in %) in Slovak Republic in 1999 to that in 2000?
Keep it short and to the point. 1.03. What is the ratio of the Area (in %) of Syrian Arab Republic in 1999 to that in 2000?
Your response must be concise. 0.86. What is the ratio of the Area (in %) of United Kingdom in 1999 to that in 2000?
Give a very brief answer. 0.94. What is the difference between the highest and the second highest Area (in %) in Middle income?
Your response must be concise. 0.38. What is the difference between the highest and the second highest Area (in %) of Slovak Republic?
Give a very brief answer. 0. What is the difference between the highest and the second highest Area (in %) of Syrian Arab Republic?
Your answer should be compact. 0.05. What is the difference between the highest and the second highest Area (in %) of United Kingdom?
Provide a succinct answer. 1.42. What is the difference between the highest and the lowest Area (in %) in Middle income?
Give a very brief answer. 1.86. What is the difference between the highest and the lowest Area (in %) in Slovak Republic?
Give a very brief answer. 1.76. What is the difference between the highest and the lowest Area (in %) of Syrian Arab Republic?
Offer a terse response. 0.12. What is the difference between the highest and the lowest Area (in %) of United Kingdom?
Give a very brief answer. 2.52. 